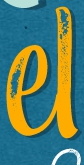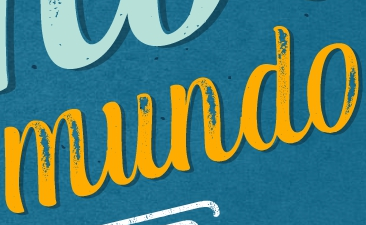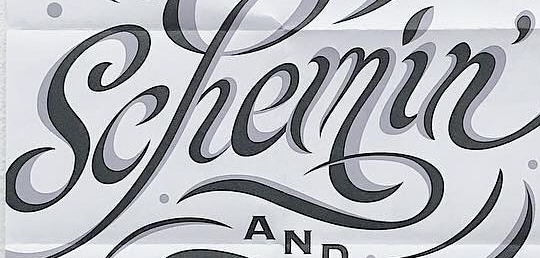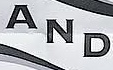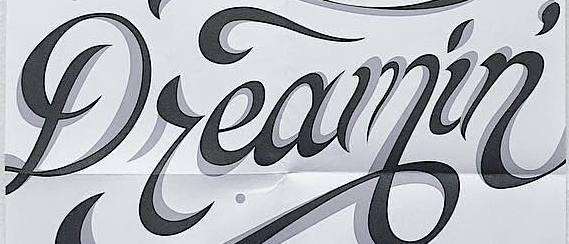Read the text content from these images in order, separated by a semicolon. el; mundo; Schemin'; AND; Dreamin' 